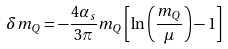Convert formula to latex. <formula><loc_0><loc_0><loc_500><loc_500>\delta m _ { Q } = - \frac { 4 \alpha _ { s } } { 3 \pi } m _ { Q } \left [ \ln \left ( \frac { m _ { Q } } { \mu } \right ) - 1 \right ]</formula> 